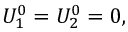<formula> <loc_0><loc_0><loc_500><loc_500>U _ { 1 } ^ { 0 } = U _ { 2 } ^ { 0 } = 0 ,</formula> 